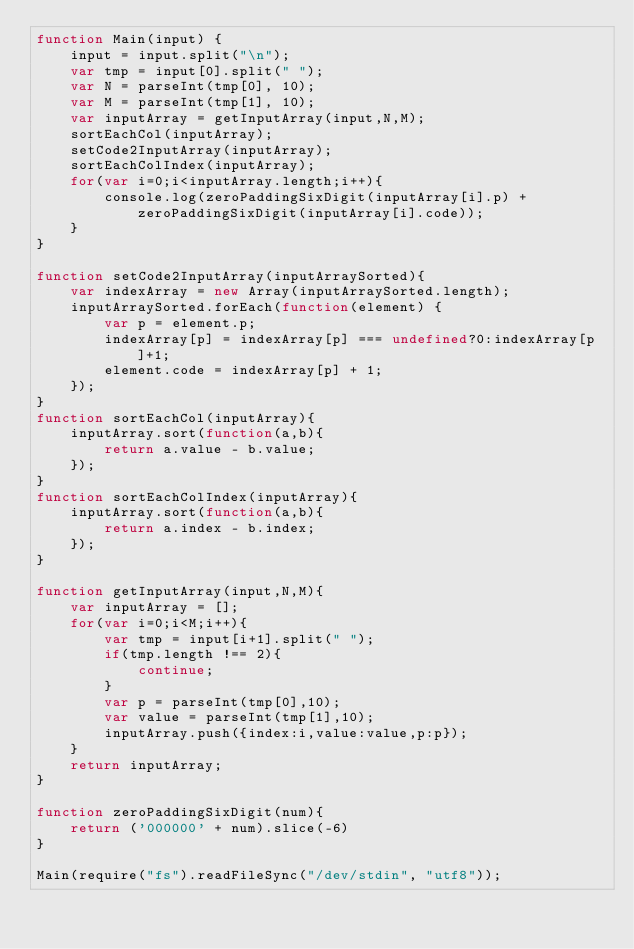Convert code to text. <code><loc_0><loc_0><loc_500><loc_500><_JavaScript_>function Main(input) {
	input = input.split("\n");
	var tmp = input[0].split(" ");
    var N = parseInt(tmp[0], 10);
    var M = parseInt(tmp[1], 10);
    var inputArray = getInputArray(input,N,M);
    sortEachCol(inputArray);
    setCode2InputArray(inputArray);
    sortEachColIndex(inputArray);
	for(var i=0;i<inputArray.length;i++){
        console.log(zeroPaddingSixDigit(inputArray[i].p) + zeroPaddingSixDigit(inputArray[i].code));
    }
}

function setCode2InputArray(inputArraySorted){
    var indexArray = new Array(inputArraySorted.length);
    inputArraySorted.forEach(function(element) {
        var p = element.p;
        indexArray[p] = indexArray[p] === undefined?0:indexArray[p]+1;
        element.code = indexArray[p] + 1;
    });
}
function sortEachCol(inputArray){
    inputArray.sort(function(a,b){
        return a.value - b.value;
    });
}
function sortEachColIndex(inputArray){
    inputArray.sort(function(a,b){
        return a.index - b.index;
    });
}

function getInputArray(input,N,M){
    var inputArray = [];
    for(var i=0;i<M;i++){
	    var tmp = input[i+1].split(" ");
        if(tmp.length !== 2){
            continue;
        }
        var p = parseInt(tmp[0],10);
        var value = parseInt(tmp[1],10);
        inputArray.push({index:i,value:value,p:p});
    }
    return inputArray;
}

function zeroPaddingSixDigit(num){
    return ('000000' + num).slice(-6)
}

Main(require("fs").readFileSync("/dev/stdin", "utf8"));</code> 